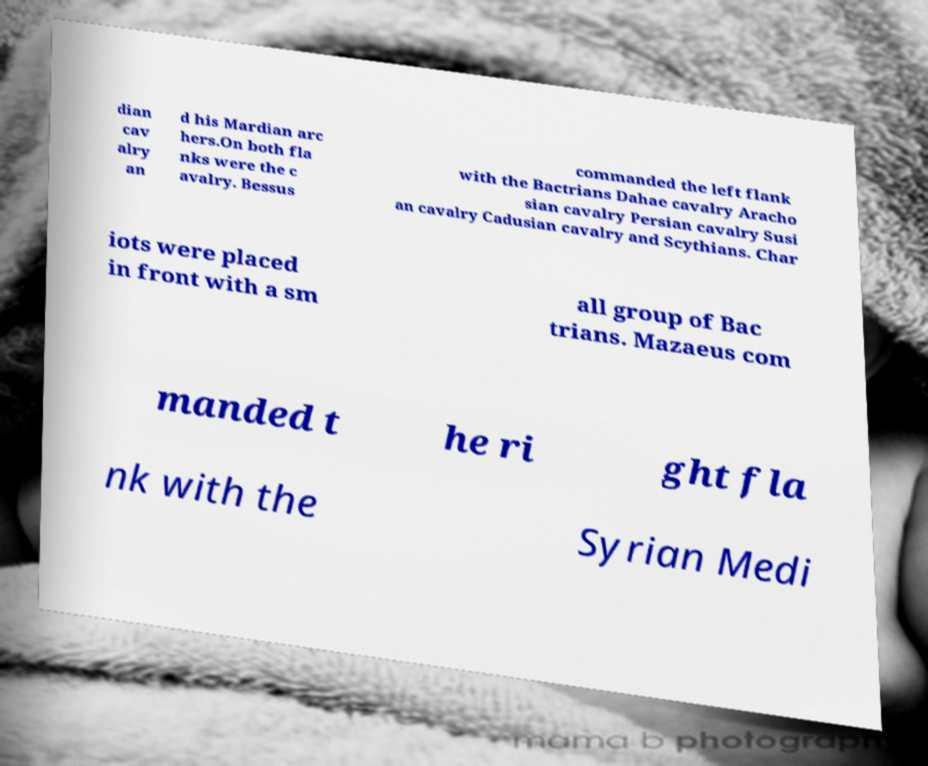Please identify and transcribe the text found in this image. dian cav alry an d his Mardian arc hers.On both fla nks were the c avalry. Bessus commanded the left flank with the Bactrians Dahae cavalry Aracho sian cavalry Persian cavalry Susi an cavalry Cadusian cavalry and Scythians. Char iots were placed in front with a sm all group of Bac trians. Mazaeus com manded t he ri ght fla nk with the Syrian Medi 